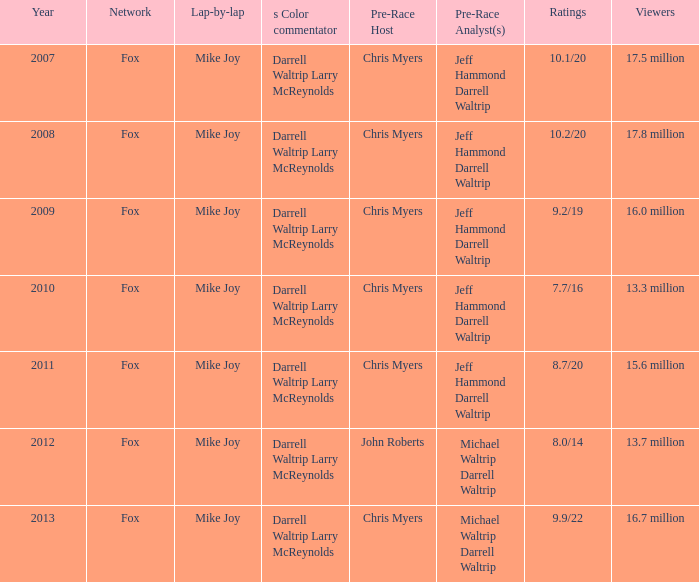I'm looking to parse the entire table for insights. Could you assist me with that? {'header': ['Year', 'Network', 'Lap-by-lap', 's Color commentator', 'Pre-Race Host', 'Pre-Race Analyst(s)', 'Ratings', 'Viewers'], 'rows': [['2007', 'Fox', 'Mike Joy', 'Darrell Waltrip Larry McReynolds', 'Chris Myers', 'Jeff Hammond Darrell Waltrip', '10.1/20', '17.5 million'], ['2008', 'Fox', 'Mike Joy', 'Darrell Waltrip Larry McReynolds', 'Chris Myers', 'Jeff Hammond Darrell Waltrip', '10.2/20', '17.8 million'], ['2009', 'Fox', 'Mike Joy', 'Darrell Waltrip Larry McReynolds', 'Chris Myers', 'Jeff Hammond Darrell Waltrip', '9.2/19', '16.0 million'], ['2010', 'Fox', 'Mike Joy', 'Darrell Waltrip Larry McReynolds', 'Chris Myers', 'Jeff Hammond Darrell Waltrip', '7.7/16', '13.3 million'], ['2011', 'Fox', 'Mike Joy', 'Darrell Waltrip Larry McReynolds', 'Chris Myers', 'Jeff Hammond Darrell Waltrip', '8.7/20', '15.6 million'], ['2012', 'Fox', 'Mike Joy', 'Darrell Waltrip Larry McReynolds', 'John Roberts', 'Michael Waltrip Darrell Waltrip', '8.0/14', '13.7 million'], ['2013', 'Fox', 'Mike Joy', 'Darrell Waltrip Larry McReynolds', 'Chris Myers', 'Michael Waltrip Darrell Waltrip', '9.9/22', '16.7 million']]} 5 million audience members? Fox. 